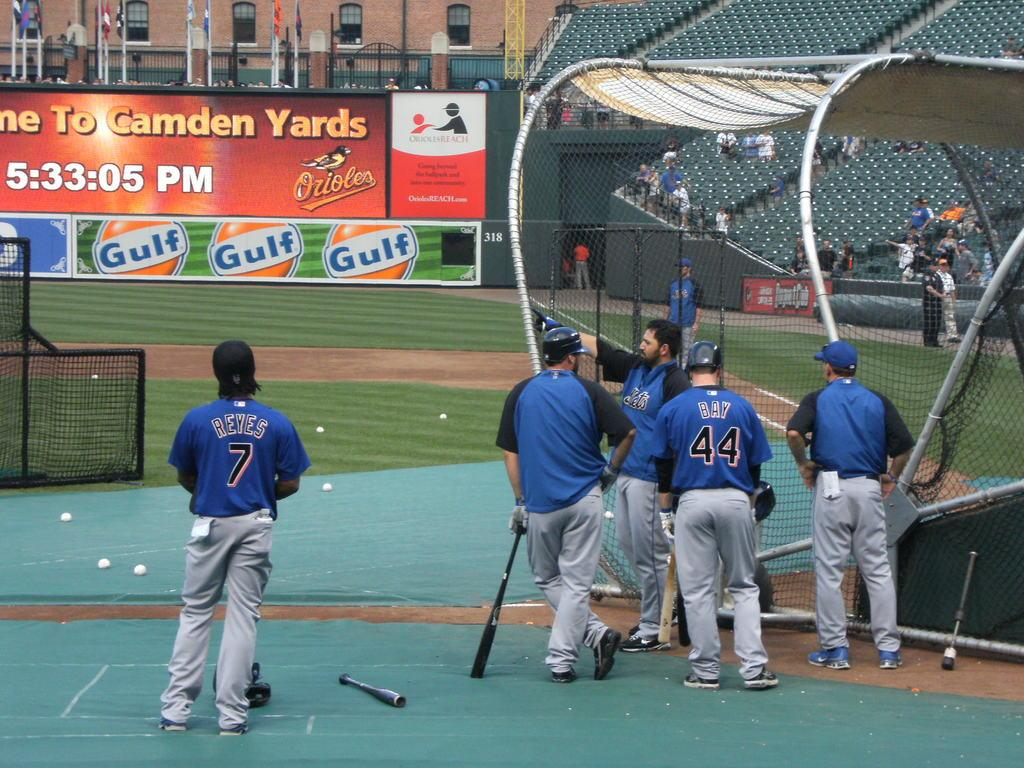Provide a one-sentence caption for the provided image. A baseball field has a banner that contains a logo for "Gulf.". 